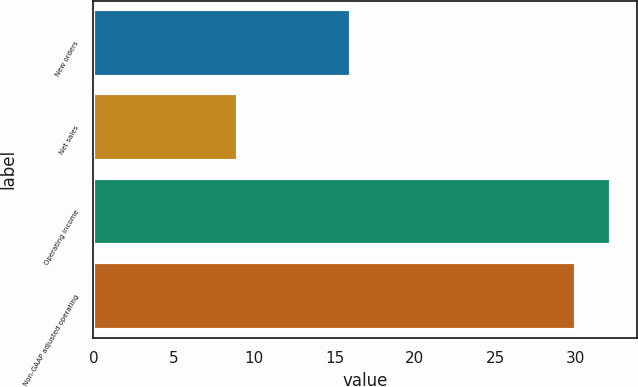Convert chart. <chart><loc_0><loc_0><loc_500><loc_500><bar_chart><fcel>New orders<fcel>Net sales<fcel>Operating income<fcel>Non-GAAP adjusted operating<nl><fcel>16<fcel>9<fcel>32.2<fcel>30<nl></chart> 